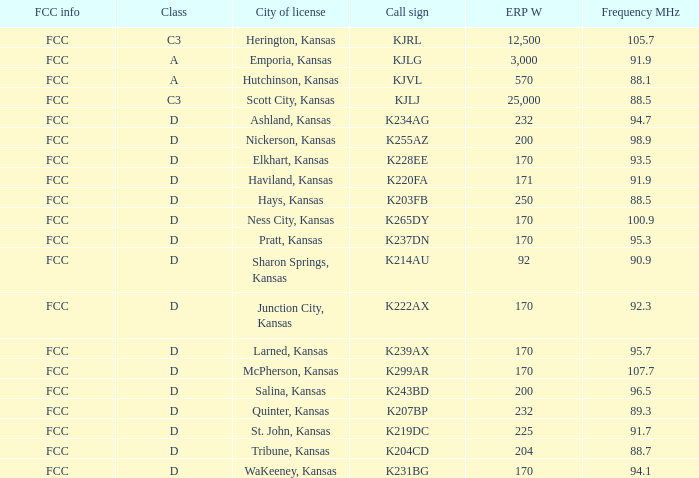Frequency MHz of 88.7 had what average erp w? 204.0. 